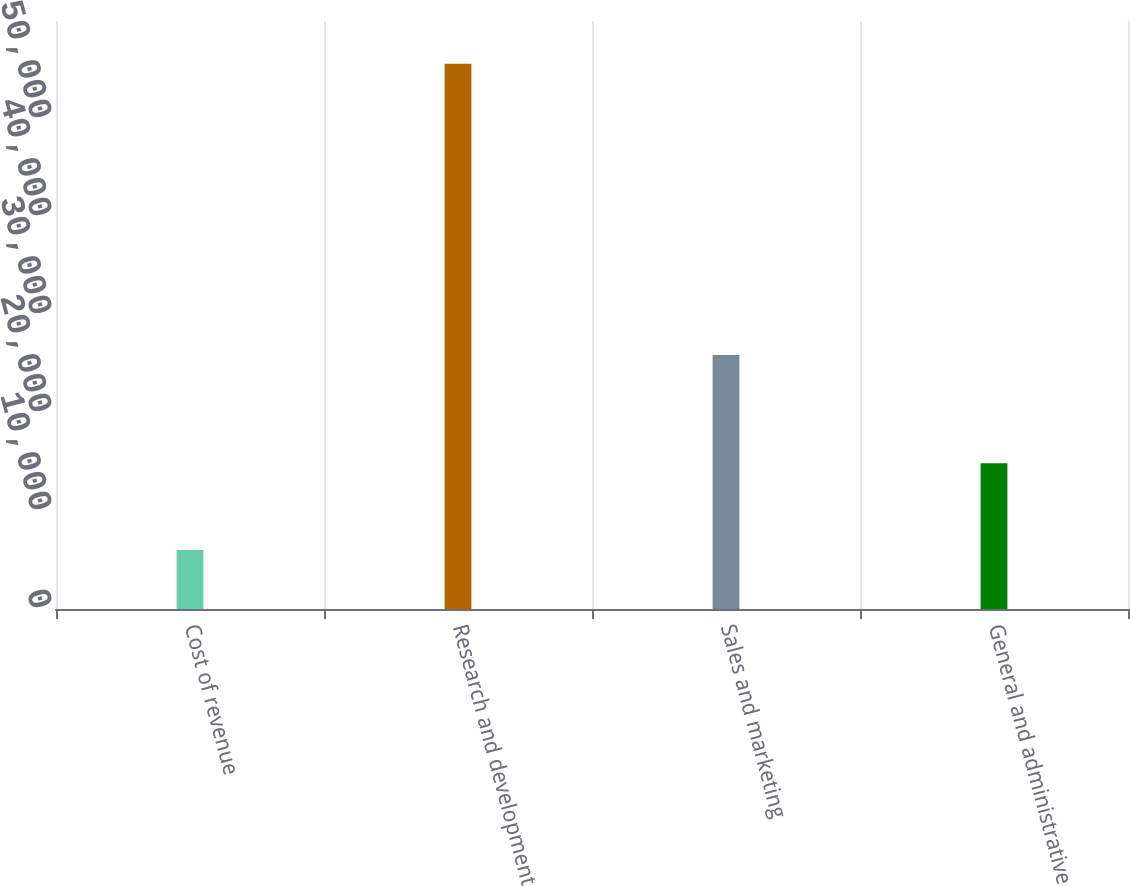Convert chart. <chart><loc_0><loc_0><loc_500><loc_500><bar_chart><fcel>Cost of revenue<fcel>Research and development<fcel>Sales and marketing<fcel>General and administrative<nl><fcel>6019<fcel>55648<fcel>25919<fcel>14868<nl></chart> 